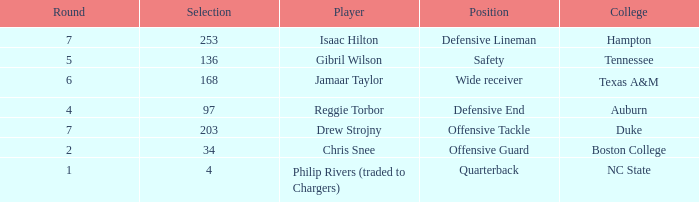Which Position has a Round larger than 5, and a Selection of 168? Wide receiver. 